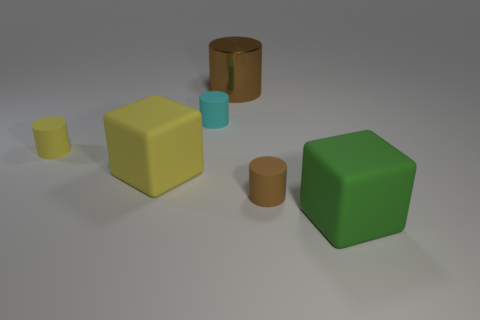What colors are the objects in this image? The image presents a variety of colors. There's a large green cube, a large yellow cube, a small yellow cylinder, and two brown cylinders. The backdrop itself is a neutral gray, providing a contrast that highlights the objects. 